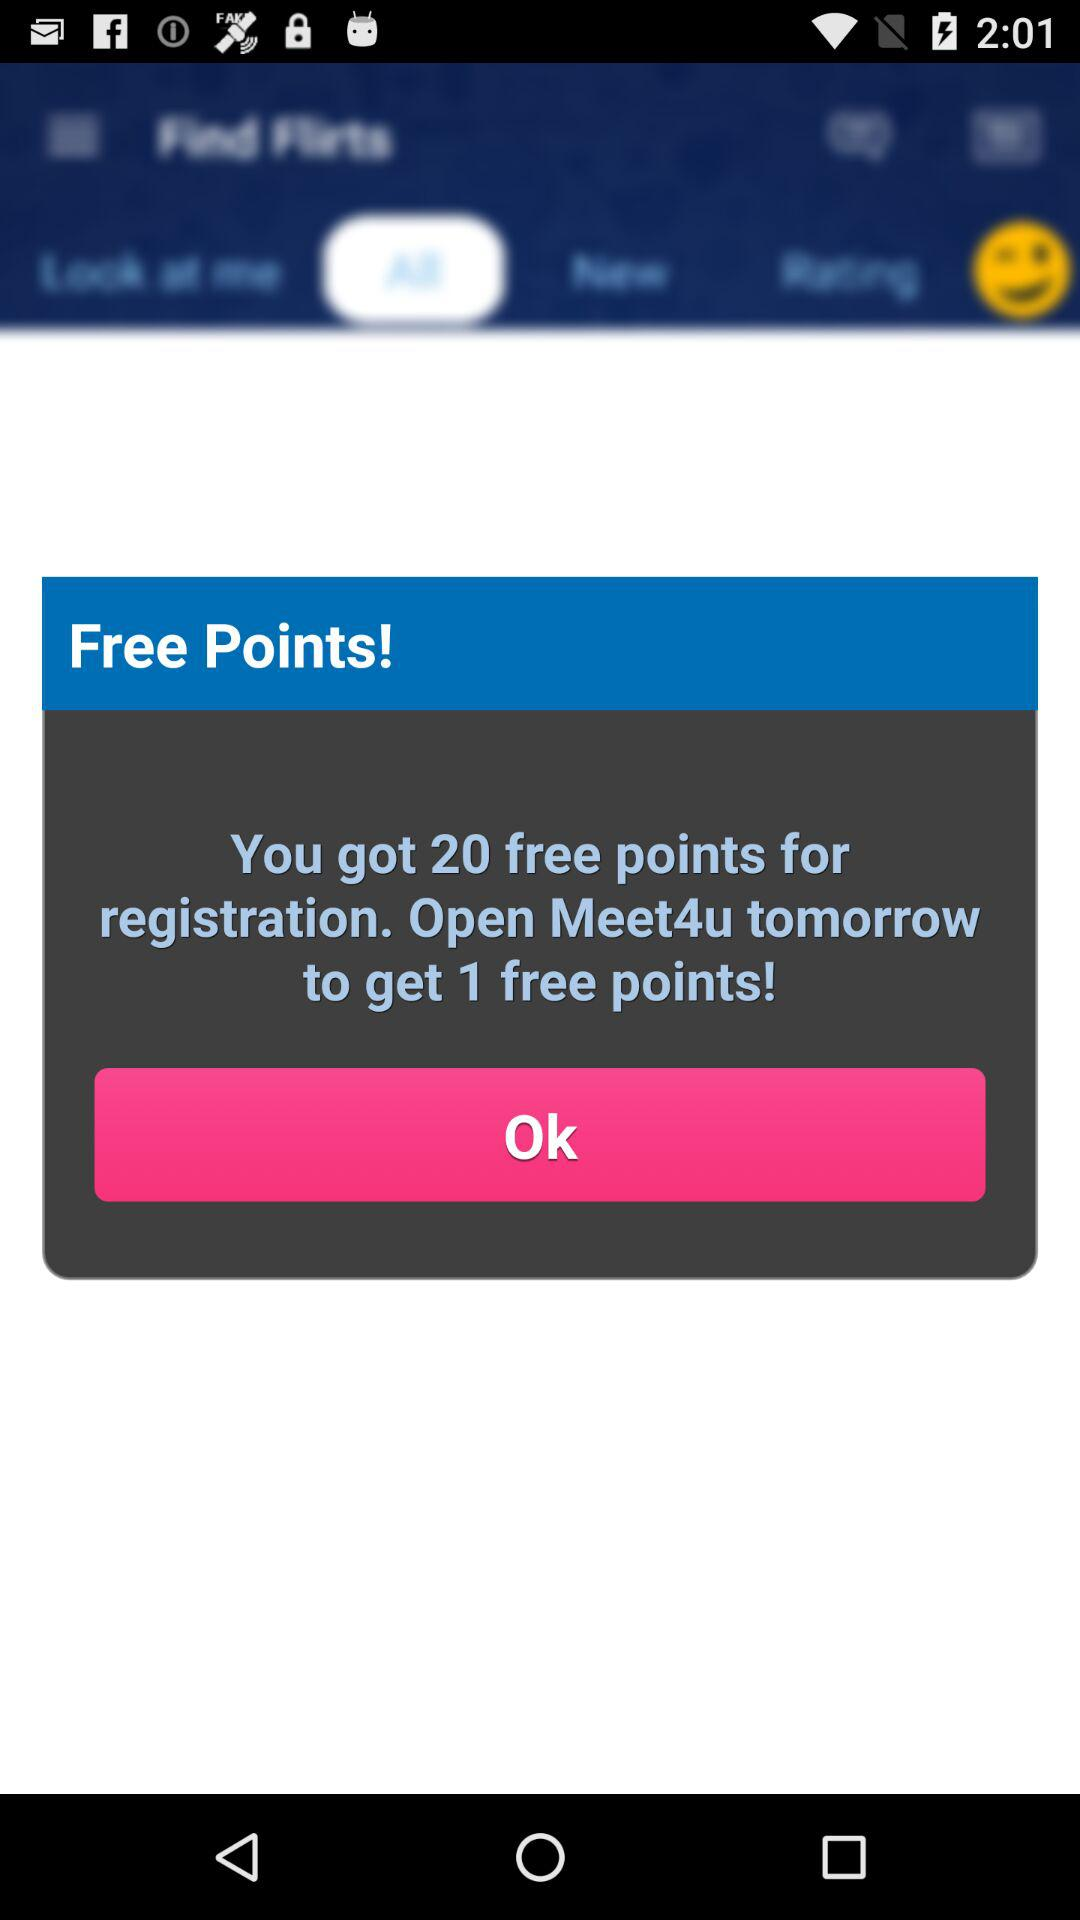How many more free points can I get by opening Meet4u tomorrow?
Answer the question using a single word or phrase. 1 